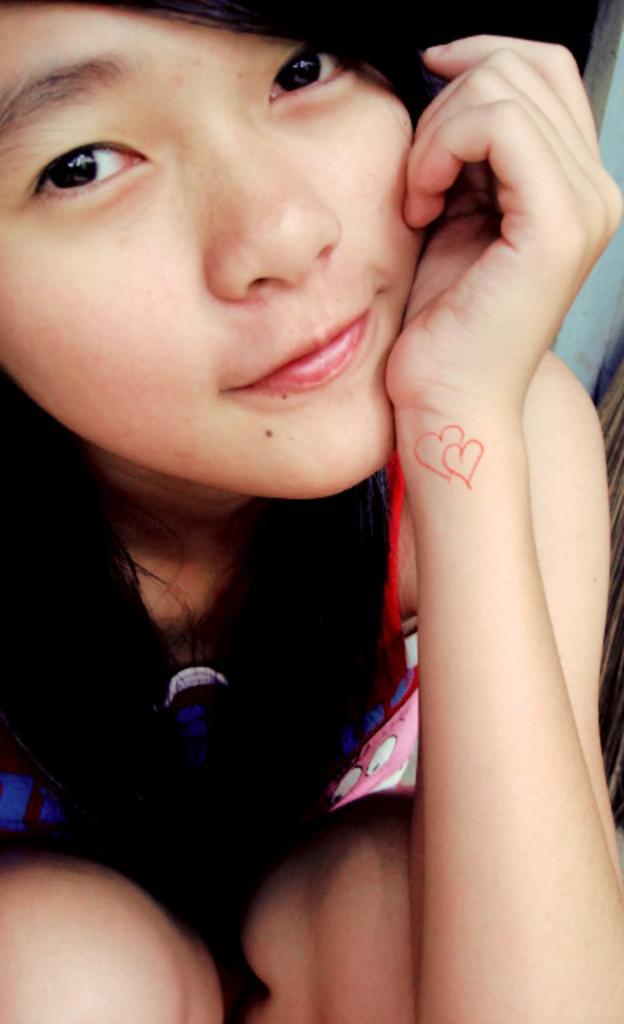Could you give a brief overview of what you see in this image? A girl is wearing clothes. 